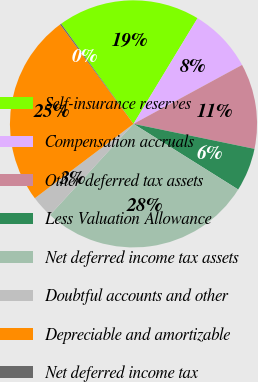Convert chart. <chart><loc_0><loc_0><loc_500><loc_500><pie_chart><fcel>Self-insurance reserves<fcel>Compensation accruals<fcel>Other deferred tax assets<fcel>Less Valuation Allowance<fcel>Net deferred income tax assets<fcel>Doubtful accounts and other<fcel>Depreciable and amortizable<fcel>Net deferred income tax<nl><fcel>18.63%<fcel>8.41%<fcel>11.16%<fcel>5.67%<fcel>27.89%<fcel>2.92%<fcel>25.15%<fcel>0.17%<nl></chart> 